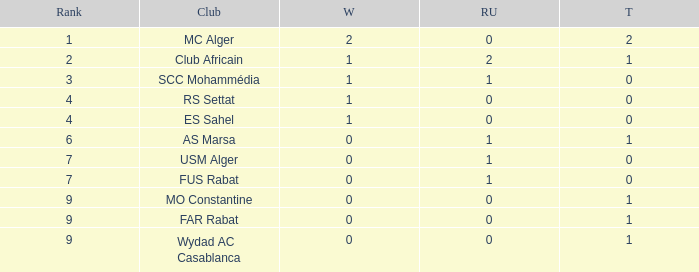Which Rank has a Third of 2, and Winners smaller than 2? None. 